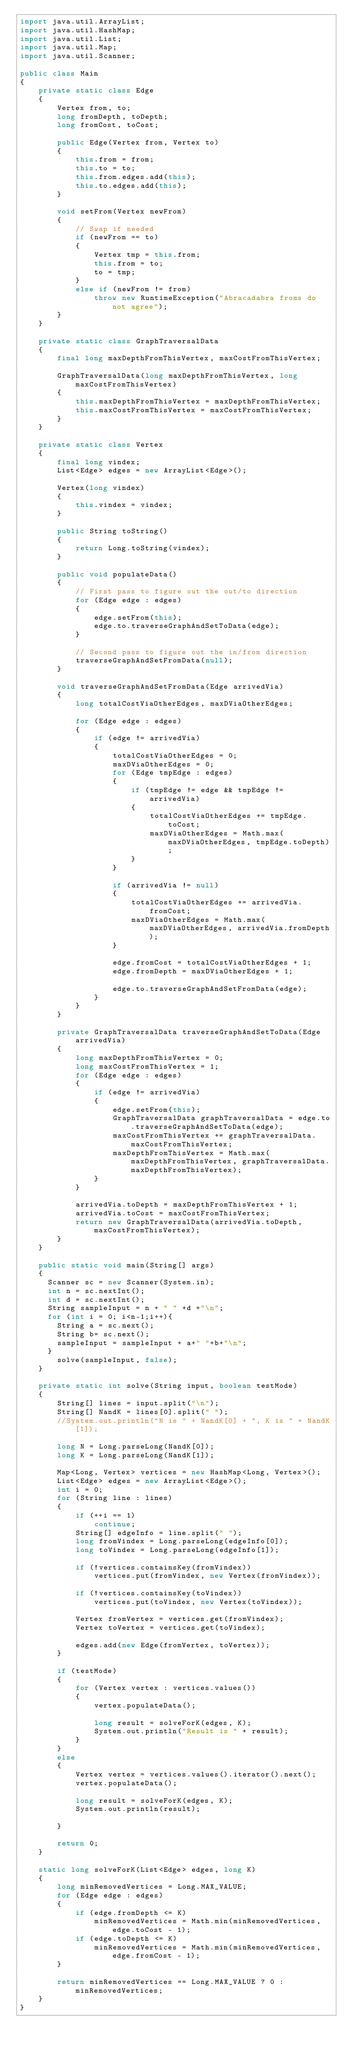Convert code to text. <code><loc_0><loc_0><loc_500><loc_500><_Java_>import java.util.ArrayList;
import java.util.HashMap;
import java.util.List;
import java.util.Map;
import java.util.Scanner;
 
public class Main
{
    private static class Edge
    {
        Vertex from, to;
        long fromDepth, toDepth;
        long fromCost, toCost;
 
        public Edge(Vertex from, Vertex to)
        {
            this.from = from;
            this.to = to;
            this.from.edges.add(this);
            this.to.edges.add(this);
        }
 
        void setFrom(Vertex newFrom)
        {
            // Swap if needed
            if (newFrom == to)
            {
                Vertex tmp = this.from;
                this.from = to;
                to = tmp;
            }
            else if (newFrom != from)
                throw new RuntimeException("Abracadabra froms do not agree");
        }
    }
 
    private static class GraphTraversalData
    {
        final long maxDepthFromThisVertex, maxCostFromThisVertex;
 
        GraphTraversalData(long maxDepthFromThisVertex, long maxCostFromThisVertex)
        {
            this.maxDepthFromThisVertex = maxDepthFromThisVertex;
            this.maxCostFromThisVertex = maxCostFromThisVertex;
        }
    }
 
    private static class Vertex
    {
        final long vindex;
        List<Edge> edges = new ArrayList<Edge>();
 
        Vertex(long vindex)
        {
            this.vindex = vindex;
        }
 
        public String toString()
        {
            return Long.toString(vindex);
        }
 
        public void populateData()
        {
            // First pass to figure out the out/to direction
            for (Edge edge : edges)
            {
                edge.setFrom(this);
                edge.to.traverseGraphAndSetToData(edge);
            }
 
            // Second pass to figure out the in/from direction
            traverseGraphAndSetFromData(null);
        }
 
        void traverseGraphAndSetFromData(Edge arrivedVia)
        {
            long totalCostViaOtherEdges, maxDViaOtherEdges;
 
            for (Edge edge : edges)
            {
                if (edge != arrivedVia)
                {
                    totalCostViaOtherEdges = 0;
                    maxDViaOtherEdges = 0;
                    for (Edge tmpEdge : edges)
                    {
                        if (tmpEdge != edge && tmpEdge != arrivedVia)
                        {
                            totalCostViaOtherEdges += tmpEdge.toCost;
                            maxDViaOtherEdges = Math.max(maxDViaOtherEdges, tmpEdge.toDepth);
                        }
                    }
 
                    if (arrivedVia != null)
                    {
                        totalCostViaOtherEdges += arrivedVia.fromCost;
                        maxDViaOtherEdges = Math.max(maxDViaOtherEdges, arrivedVia.fromDepth);
                    }
 
                    edge.fromCost = totalCostViaOtherEdges + 1;
                    edge.fromDepth = maxDViaOtherEdges + 1;
 
                    edge.to.traverseGraphAndSetFromData(edge);
                }
            }
        }
 
        private GraphTraversalData traverseGraphAndSetToData(Edge arrivedVia)
        {
            long maxDepthFromThisVertex = 0;
            long maxCostFromThisVertex = 1;
            for (Edge edge : edges)
            {
                if (edge != arrivedVia)
                {
                    edge.setFrom(this);
                    GraphTraversalData graphTraversalData = edge.to.traverseGraphAndSetToData(edge);
                    maxCostFromThisVertex += graphTraversalData.maxCostFromThisVertex;
                    maxDepthFromThisVertex = Math.max(maxDepthFromThisVertex, graphTraversalData.maxDepthFromThisVertex);
                }
            }
 
            arrivedVia.toDepth = maxDepthFromThisVertex + 1;
            arrivedVia.toCost = maxCostFromThisVertex;
            return new GraphTraversalData(arrivedVia.toDepth, maxCostFromThisVertex);
        }
    }
 
    public static void main(String[] args)
    {
      Scanner sc = new Scanner(System.in);
      int n = sc.nextInt();
      int d = sc.nextInt();
      String sampleInput = n + " " +d +"\n";
      for (int i = 0; i<n-1;i++){
        String a = sc.next();
        String b= sc.next();
        sampleInput = sampleInput + a+" "+b+"\n";
      }
        solve(sampleInput, false);
    }
 
    private static int solve(String input, boolean testMode)
    {
        String[] lines = input.split("\n");
        String[] NandK = lines[0].split(" ");
        //System.out.println("N is " + NandK[0] + ", K is " + NandK[1]);
 
        long N = Long.parseLong(NandK[0]);
        long K = Long.parseLong(NandK[1]);
 
        Map<Long, Vertex> vertices = new HashMap<Long, Vertex>();
        List<Edge> edges = new ArrayList<Edge>();
        int i = 0;
        for (String line : lines)
        {
            if (++i == 1)
                continue;
            String[] edgeInfo = line.split(" ");
            long fromVindex = Long.parseLong(edgeInfo[0]);
            long toVindex = Long.parseLong(edgeInfo[1]);
 
            if (!vertices.containsKey(fromVindex))
                vertices.put(fromVindex, new Vertex(fromVindex));
 
            if (!vertices.containsKey(toVindex))
                vertices.put(toVindex, new Vertex(toVindex));
 
            Vertex fromVertex = vertices.get(fromVindex);
            Vertex toVertex = vertices.get(toVindex);
 
            edges.add(new Edge(fromVertex, toVertex));
        }
 
        if (testMode)
        {
            for (Vertex vertex : vertices.values())
            {
                vertex.populateData();
 
                long result = solveForK(edges, K);
                System.out.println("Result is " + result);
            }
        }
        else
        {
            Vertex vertex = vertices.values().iterator().next();
            vertex.populateData();
 
            long result = solveForK(edges, K);
            System.out.println(result);
            
        }
 
        return 0;
    }
 
    static long solveForK(List<Edge> edges, long K)
    {
        long minRemovedVertices = Long.MAX_VALUE;
        for (Edge edge : edges)
        {
            if (edge.fromDepth <= K)
                minRemovedVertices = Math.min(minRemovedVertices, edge.toCost - 1);
            if (edge.toDepth <= K)
                minRemovedVertices = Math.min(minRemovedVertices, edge.fromCost - 1);
        }
 
        return minRemovedVertices == Long.MAX_VALUE ? 0 : minRemovedVertices;
    }
}</code> 